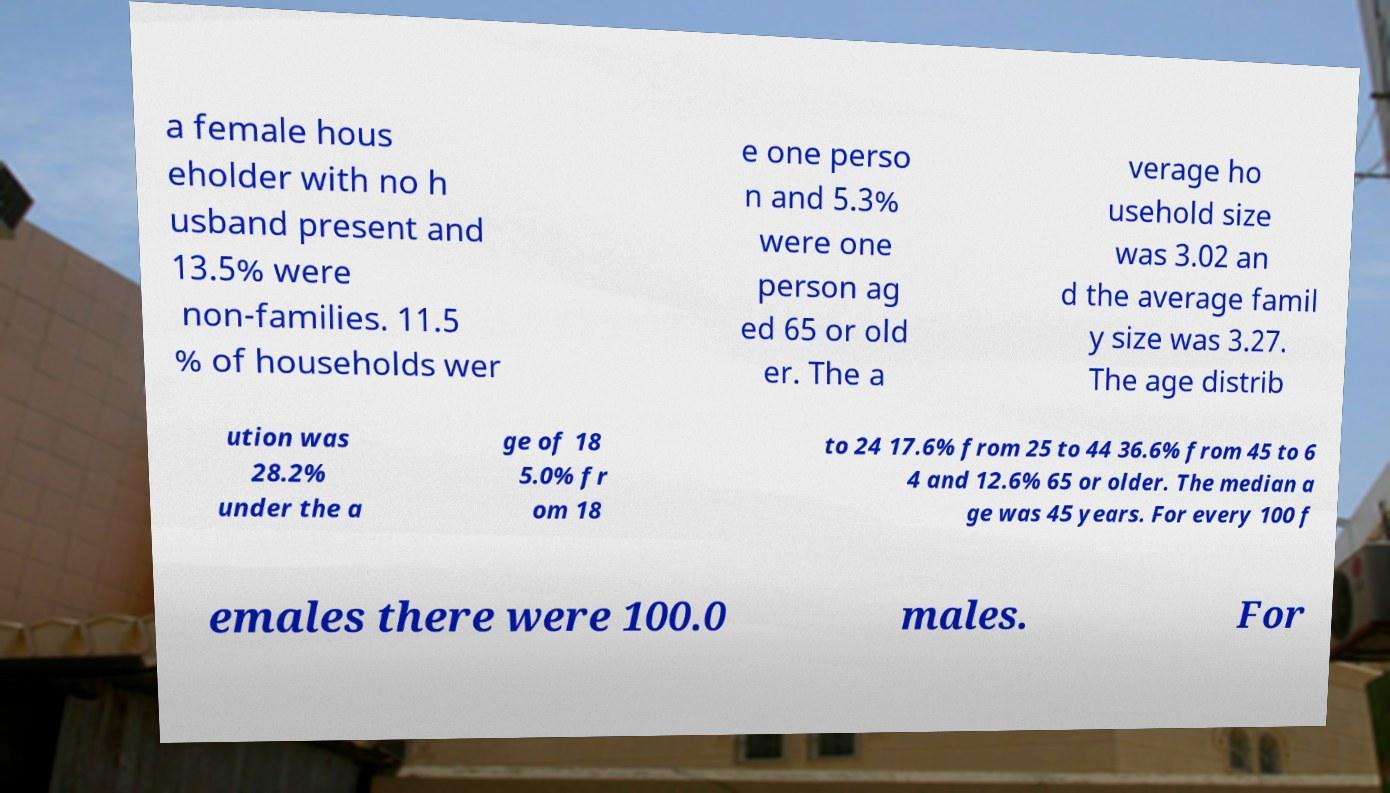Please identify and transcribe the text found in this image. a female hous eholder with no h usband present and 13.5% were non-families. 11.5 % of households wer e one perso n and 5.3% were one person ag ed 65 or old er. The a verage ho usehold size was 3.02 an d the average famil y size was 3.27. The age distrib ution was 28.2% under the a ge of 18 5.0% fr om 18 to 24 17.6% from 25 to 44 36.6% from 45 to 6 4 and 12.6% 65 or older. The median a ge was 45 years. For every 100 f emales there were 100.0 males. For 